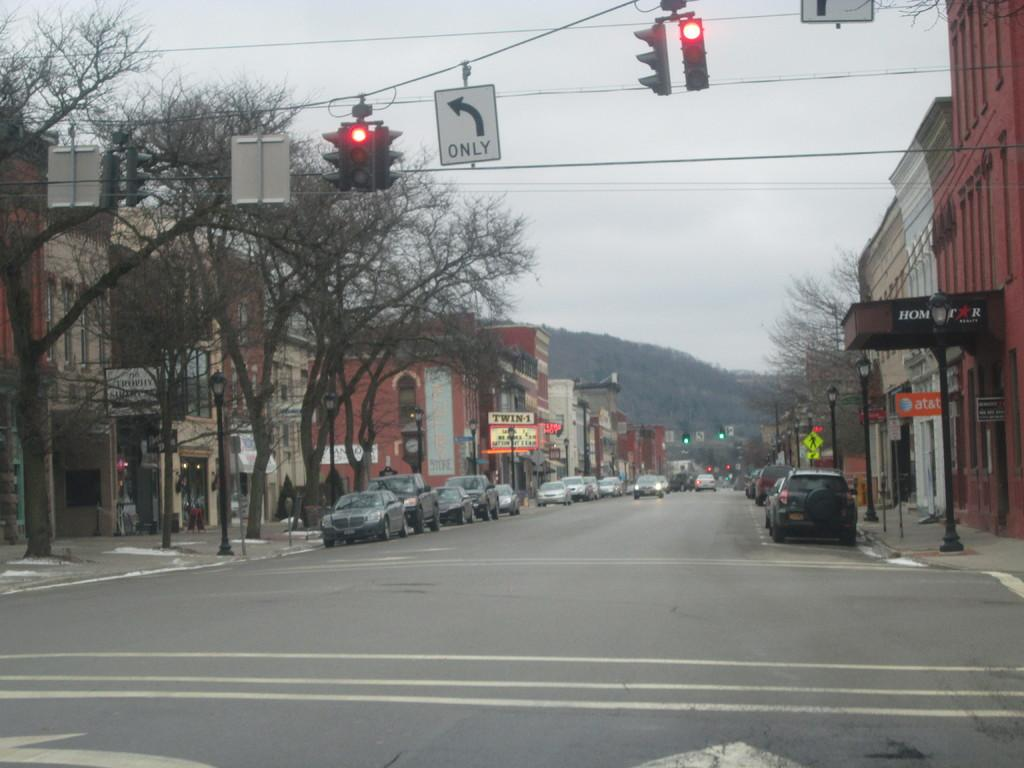<image>
Describe the image concisely. An intersection with red lights and a sign that says left turns only. 